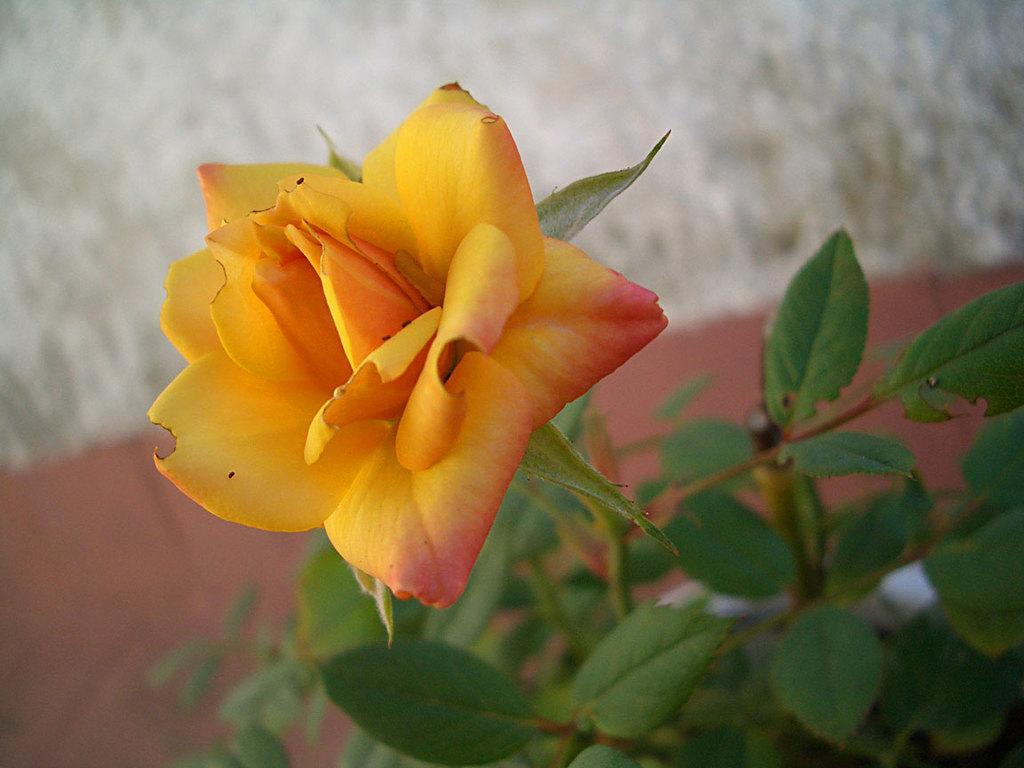Can you describe this image briefly? In this picture we can see a flower, leaves and in the background it is blurry. 